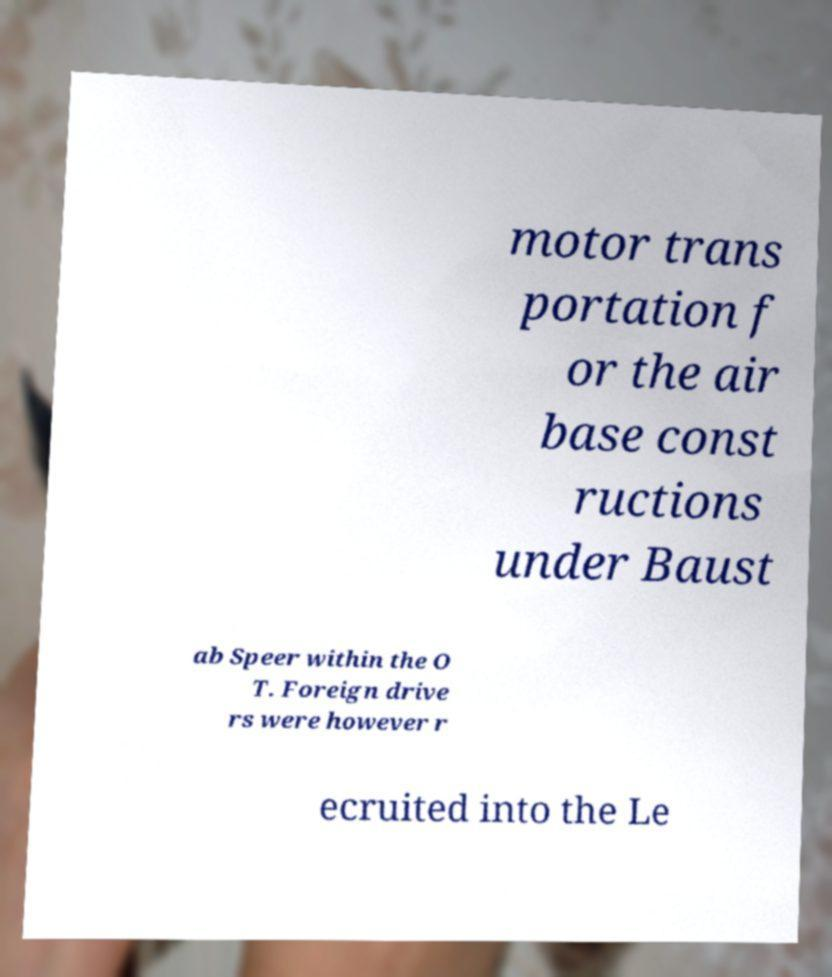Can you read and provide the text displayed in the image?This photo seems to have some interesting text. Can you extract and type it out for me? motor trans portation f or the air base const ructions under Baust ab Speer within the O T. Foreign drive rs were however r ecruited into the Le 